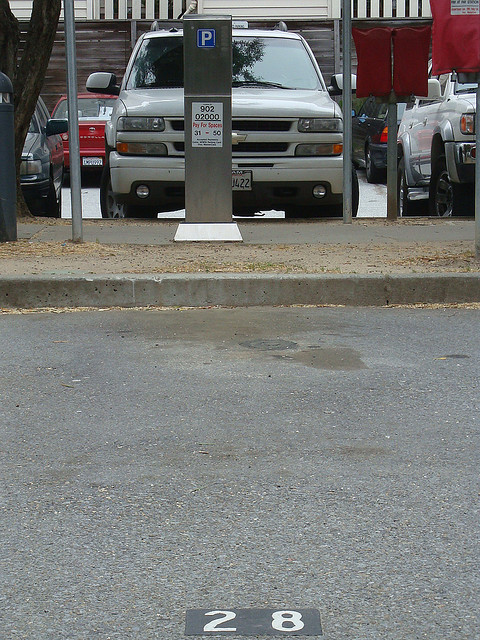If this parking spot were a magical portal, where would it lead? Imagine if this parking spot were a magical portal that transported you to a bustling ancient marketplace filled with exotic goods and vibrant characters. Here, you could explore stalls selling rare spices, artisanal crafts, and colorful textiles, all while mingling with traders who have countless stories from distant lands. The air would be filled with the sounds of lively bartering, traditional music, and the scent of foreign delicacies. What unique experiences could one have in this marketplace? In this fantastical marketplace, you could embark on a treasure hunt, guided by a mysterious map leading you to hidden gems and ancient artifacts. Participate in vibrant cultural festivals, where traditional dances, music, and cuisine are celebrated. Meet with a master storyteller who spins ancient legends and myths, immersing you in a world of fantasy and adventure. It's a place where every turn reveals a new wonder, transporting you to a time long forgotten. 